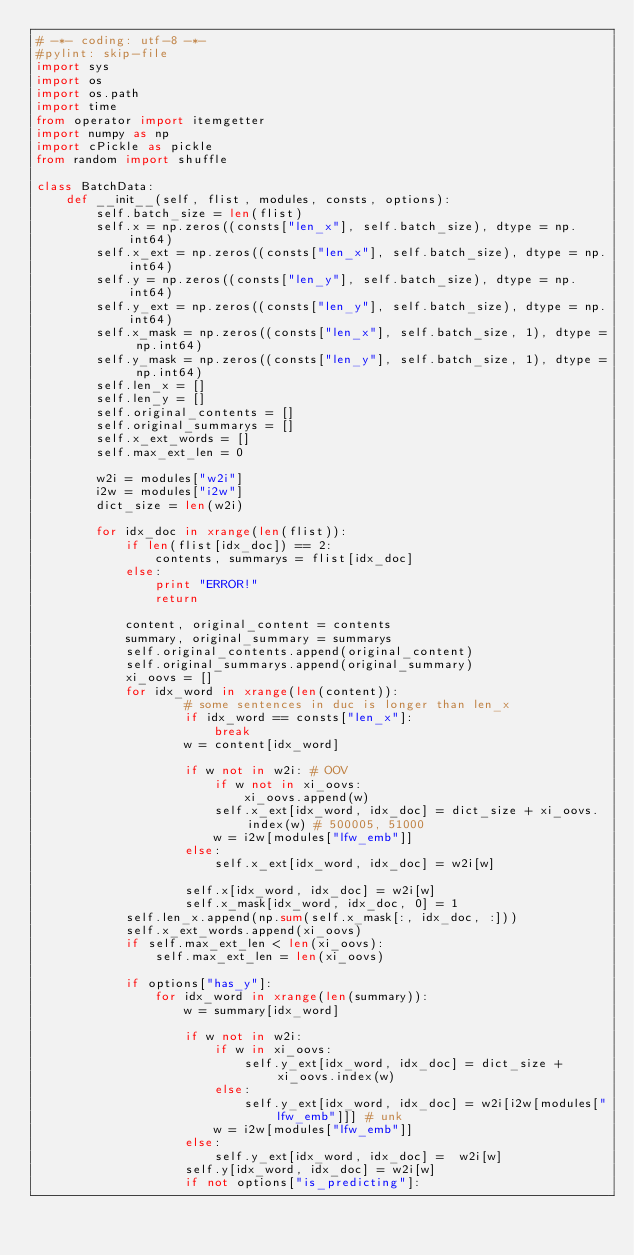<code> <loc_0><loc_0><loc_500><loc_500><_Python_># -*- coding: utf-8 -*-
#pylint: skip-file
import sys
import os
import os.path
import time
from operator import itemgetter
import numpy as np
import cPickle as pickle
from random import shuffle

class BatchData:
    def __init__(self, flist, modules, consts, options):
        self.batch_size = len(flist) 
        self.x = np.zeros((consts["len_x"], self.batch_size), dtype = np.int64)
        self.x_ext = np.zeros((consts["len_x"], self.batch_size), dtype = np.int64)
        self.y = np.zeros((consts["len_y"], self.batch_size), dtype = np.int64)
        self.y_ext = np.zeros((consts["len_y"], self.batch_size), dtype = np.int64)
        self.x_mask = np.zeros((consts["len_x"], self.batch_size, 1), dtype = np.int64)
        self.y_mask = np.zeros((consts["len_y"], self.batch_size, 1), dtype = np.int64)
        self.len_x = []
        self.len_y = []
        self.original_contents = []
        self.original_summarys = []
        self.x_ext_words = []
        self.max_ext_len = 0

        w2i = modules["w2i"]
        i2w = modules["i2w"]
        dict_size = len(w2i)

        for idx_doc in xrange(len(flist)):
            if len(flist[idx_doc]) == 2:
                contents, summarys = flist[idx_doc]
            else:
                print "ERROR!"
                return
            
            content, original_content = contents
            summary, original_summary = summarys
            self.original_contents.append(original_content)
            self.original_summarys.append(original_summary)
            xi_oovs = []
            for idx_word in xrange(len(content)):
                    # some sentences in duc is longer than len_x
                    if idx_word == consts["len_x"]:
                        break
                    w = content[idx_word]
                    
                    if w not in w2i: # OOV
                        if w not in xi_oovs:
                            xi_oovs.append(w)
                        self.x_ext[idx_word, idx_doc] = dict_size + xi_oovs.index(w) # 500005, 51000
                        w = i2w[modules["lfw_emb"]]
                    else:
                        self.x_ext[idx_word, idx_doc] = w2i[w]
                    
                    self.x[idx_word, idx_doc] = w2i[w]
                    self.x_mask[idx_word, idx_doc, 0] = 1
            self.len_x.append(np.sum(self.x_mask[:, idx_doc, :]))
            self.x_ext_words.append(xi_oovs)
            if self.max_ext_len < len(xi_oovs):
                self.max_ext_len = len(xi_oovs)

            if options["has_y"]:
                for idx_word in xrange(len(summary)):
                    w = summary[idx_word]
                    
                    if w not in w2i:
                        if w in xi_oovs:
                            self.y_ext[idx_word, idx_doc] = dict_size + xi_oovs.index(w)
                        else:
                            self.y_ext[idx_word, idx_doc] = w2i[i2w[modules["lfw_emb"]]] # unk
                        w = i2w[modules["lfw_emb"]] 
                    else:
                        self.y_ext[idx_word, idx_doc] =  w2i[w]
                    self.y[idx_word, idx_doc] = w2i[w]
                    if not options["is_predicting"]:</code> 